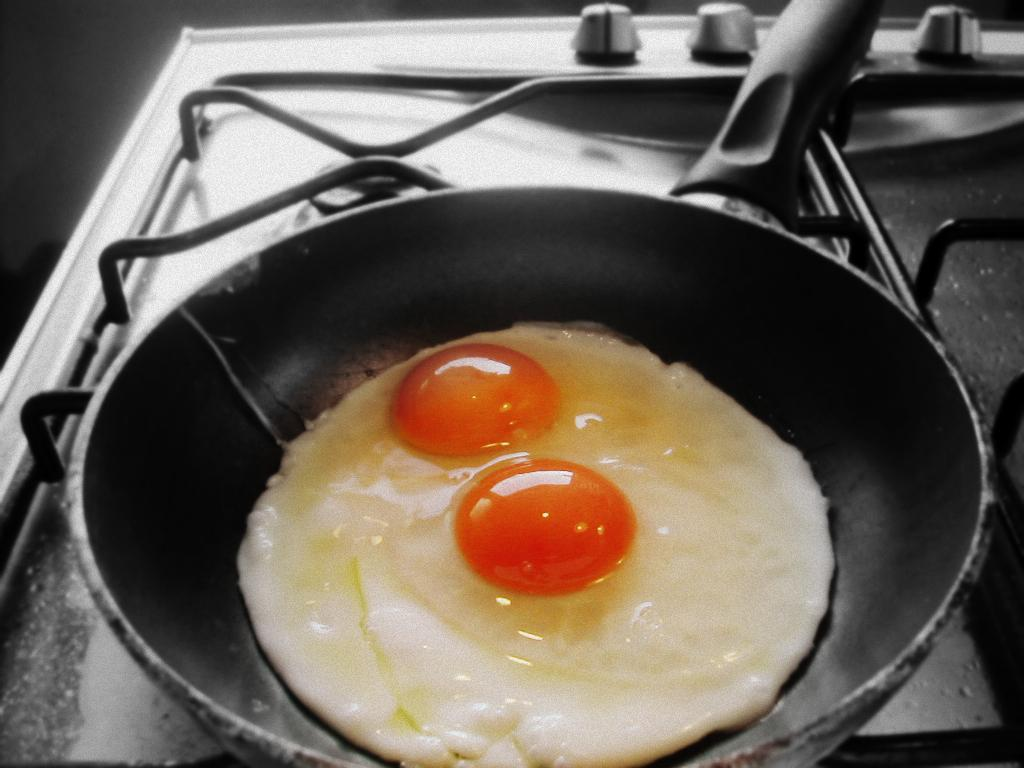What is in the pan that is visible in the image? There is food in the pan in the image. Where is the pan located in the image? The pan is on a stove in the image. What color is the background of the image? The background of the image is black. What type of bead is being used in the meeting in the image? There is no meeting or bead present in the image; it features a pan with food on a stove with a black background. 